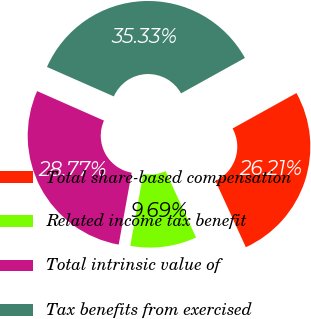Convert chart. <chart><loc_0><loc_0><loc_500><loc_500><pie_chart><fcel>Total share-based compensation<fcel>Related income tax benefit<fcel>Total intrinsic value of<fcel>Tax benefits from exercised<nl><fcel>26.21%<fcel>9.69%<fcel>28.77%<fcel>35.33%<nl></chart> 